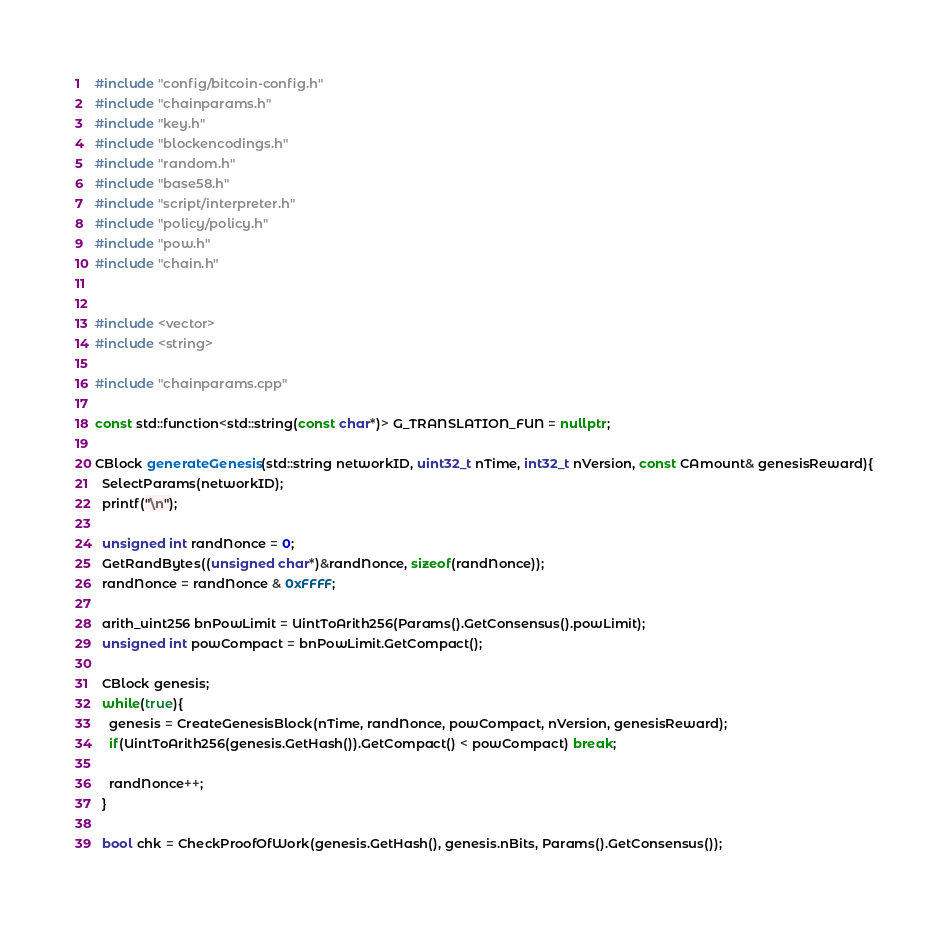Convert code to text. <code><loc_0><loc_0><loc_500><loc_500><_C++_>#include "config/bitcoin-config.h"
#include "chainparams.h"
#include "key.h"
#include "blockencodings.h"
#include "random.h"
#include "base58.h"
#include "script/interpreter.h"
#include "policy/policy.h"
#include "pow.h"
#include "chain.h"


#include <vector>
#include <string>

#include "chainparams.cpp"

const std::function<std::string(const char*)> G_TRANSLATION_FUN = nullptr;

CBlock generateGenesis(std::string networkID, uint32_t nTime, int32_t nVersion, const CAmount& genesisReward){
  SelectParams(networkID);
  printf("\n");

  unsigned int randNonce = 0;
  GetRandBytes((unsigned char*)&randNonce, sizeof(randNonce));
  randNonce = randNonce & 0xFFFF;

  arith_uint256 bnPowLimit = UintToArith256(Params().GetConsensus().powLimit);
  unsigned int powCompact = bnPowLimit.GetCompact();

  CBlock genesis;
  while(true){
    genesis = CreateGenesisBlock(nTime, randNonce, powCompact, nVersion, genesisReward);
    if(UintToArith256(genesis.GetHash()).GetCompact() < powCompact) break;

    randNonce++;
  }

  bool chk = CheckProofOfWork(genesis.GetHash(), genesis.nBits, Params().GetConsensus());</code> 